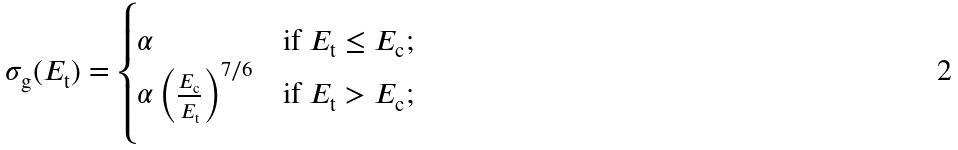<formula> <loc_0><loc_0><loc_500><loc_500>\sigma _ { \text {g} } ( E _ { \text {t} } ) = \begin{cases} \alpha & \text {if $E_{\text {t}}\leq E_{\text {c}}$;} \\ \alpha \left ( \frac { E _ { \text {c} } } { E _ { \text {t} } } \right ) ^ { 7 / 6 } & \text {if     $E_{\text {t}}>E_{\text {c}}$;} \end{cases}</formula> 